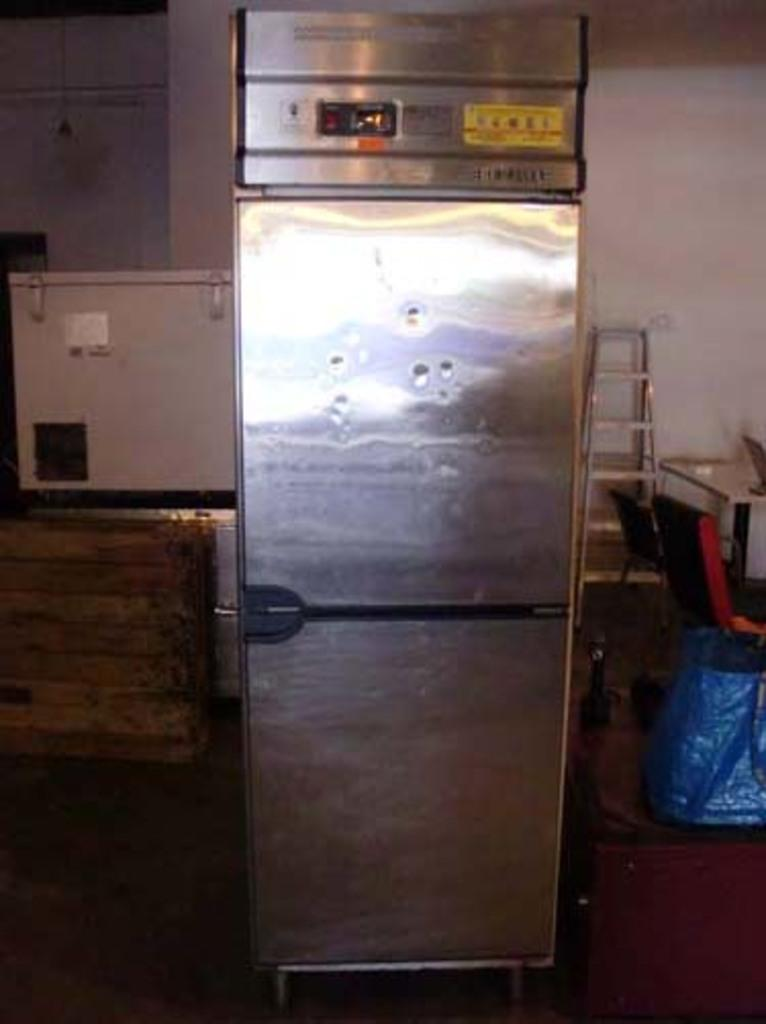<image>
Provide a brief description of the given image. A freezer in a dirty room has a sticker on it that says Warning. 